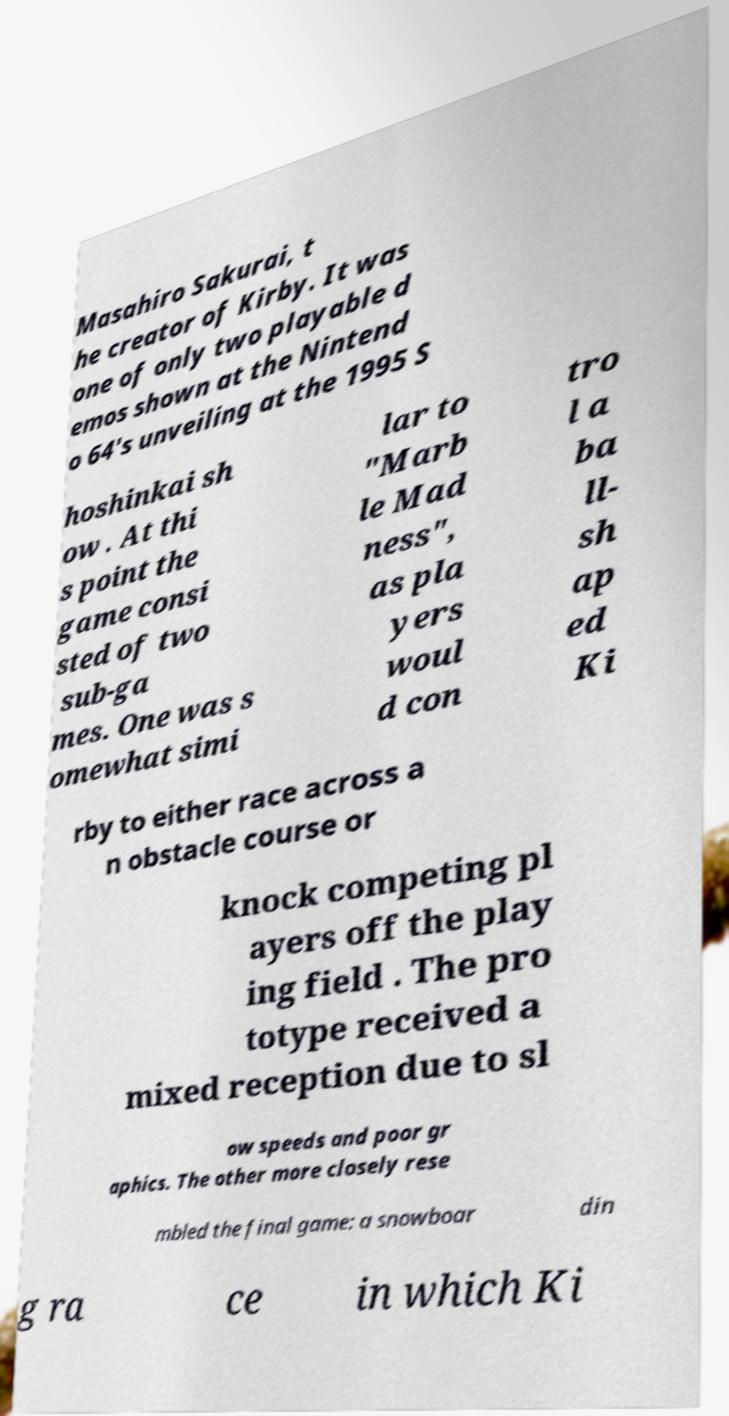Can you accurately transcribe the text from the provided image for me? Masahiro Sakurai, t he creator of Kirby. It was one of only two playable d emos shown at the Nintend o 64's unveiling at the 1995 S hoshinkai sh ow . At thi s point the game consi sted of two sub-ga mes. One was s omewhat simi lar to "Marb le Mad ness", as pla yers woul d con tro l a ba ll- sh ap ed Ki rby to either race across a n obstacle course or knock competing pl ayers off the play ing field . The pro totype received a mixed reception due to sl ow speeds and poor gr aphics. The other more closely rese mbled the final game: a snowboar din g ra ce in which Ki 